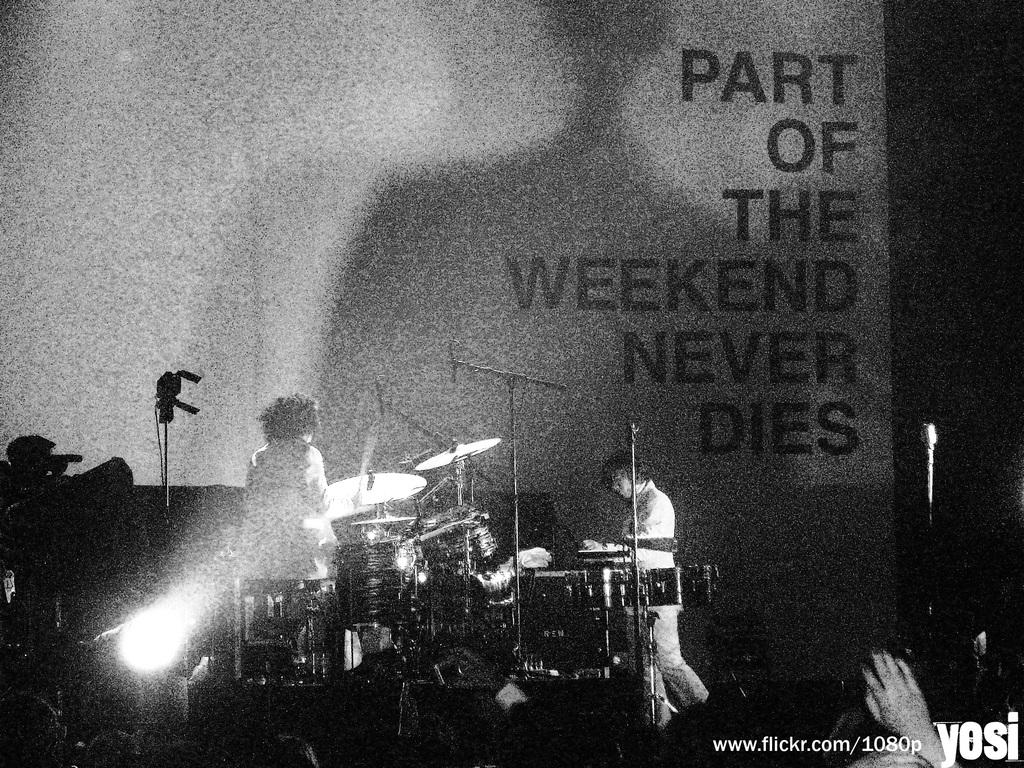What is the color scheme of the image? The image is black and white. How many people are in the image? There are two persons in the image. What instruments are they playing? They are playing a drum and a guitar. Where are they performing? They are on a stage. What can be seen on the wall behind them? There is wallpaper on the wall behind them. What type of friction is being generated by the drumsticks on the drum in the image? There is no information about friction in the image, as it is a black and white photograph of two people playing instruments on a stage. --- Facts: 1. There is a car in the image. 2. The car is red. 3. The car has four wheels. 4. There is a road in the image. 5. The road is paved. Absurd Topics: rainbow, dance, volcano Conversation: What is the main subject of the image? The main subject of the image is a car. What color is the car? The car is red. How many wheels does the car have? The car has four wheels. What is the setting of the image? The image shows a car on a road. What type of road is visible in the image? The road is paved. Reasoning: Let's think step by step in order to produce the conversation. We start by identifying the main subject of the image, which is the car. Then, we describe the color and number of wheels of the car. Next, we mention the setting of the image, which is a car on a road. Finally, we provide a detail about the road, stating that it is paved. Absurd Question/Answer: Can you see a rainbow arching over the car in the image? No, there is no rainbow present in the image. Are the people in the car dancing to music while driving? There is no indication of people inside the car or any dancing in the image. 